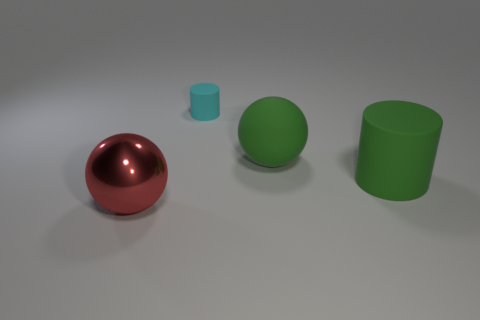Are there any other things that are the same material as the large red sphere?
Make the answer very short. No. Are there any other things that have the same size as the cyan rubber thing?
Offer a very short reply. No. The big green thing in front of the large ball to the right of the cyan matte cylinder is made of what material?
Your answer should be very brief. Rubber. Is the number of matte objects greater than the number of tiny brown balls?
Provide a succinct answer. Yes. Does the big rubber cylinder have the same color as the matte sphere?
Make the answer very short. Yes. What is the material of the other sphere that is the same size as the red metallic ball?
Keep it short and to the point. Rubber. Does the green cylinder have the same material as the big green ball?
Your answer should be very brief. Yes. What number of big green things have the same material as the cyan cylinder?
Your answer should be compact. 2. What number of objects are things that are in front of the tiny cylinder or things right of the cyan rubber thing?
Offer a very short reply. 3. Is the number of rubber cylinders that are to the left of the metallic object greater than the number of big spheres to the right of the large matte sphere?
Provide a succinct answer. No. 